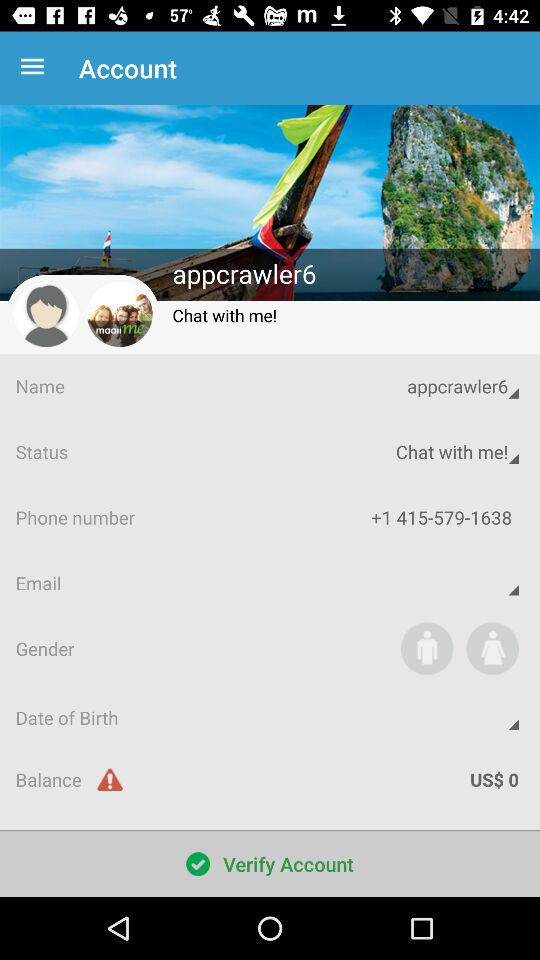How much is the balance in the account? The balance is US$ 0. 